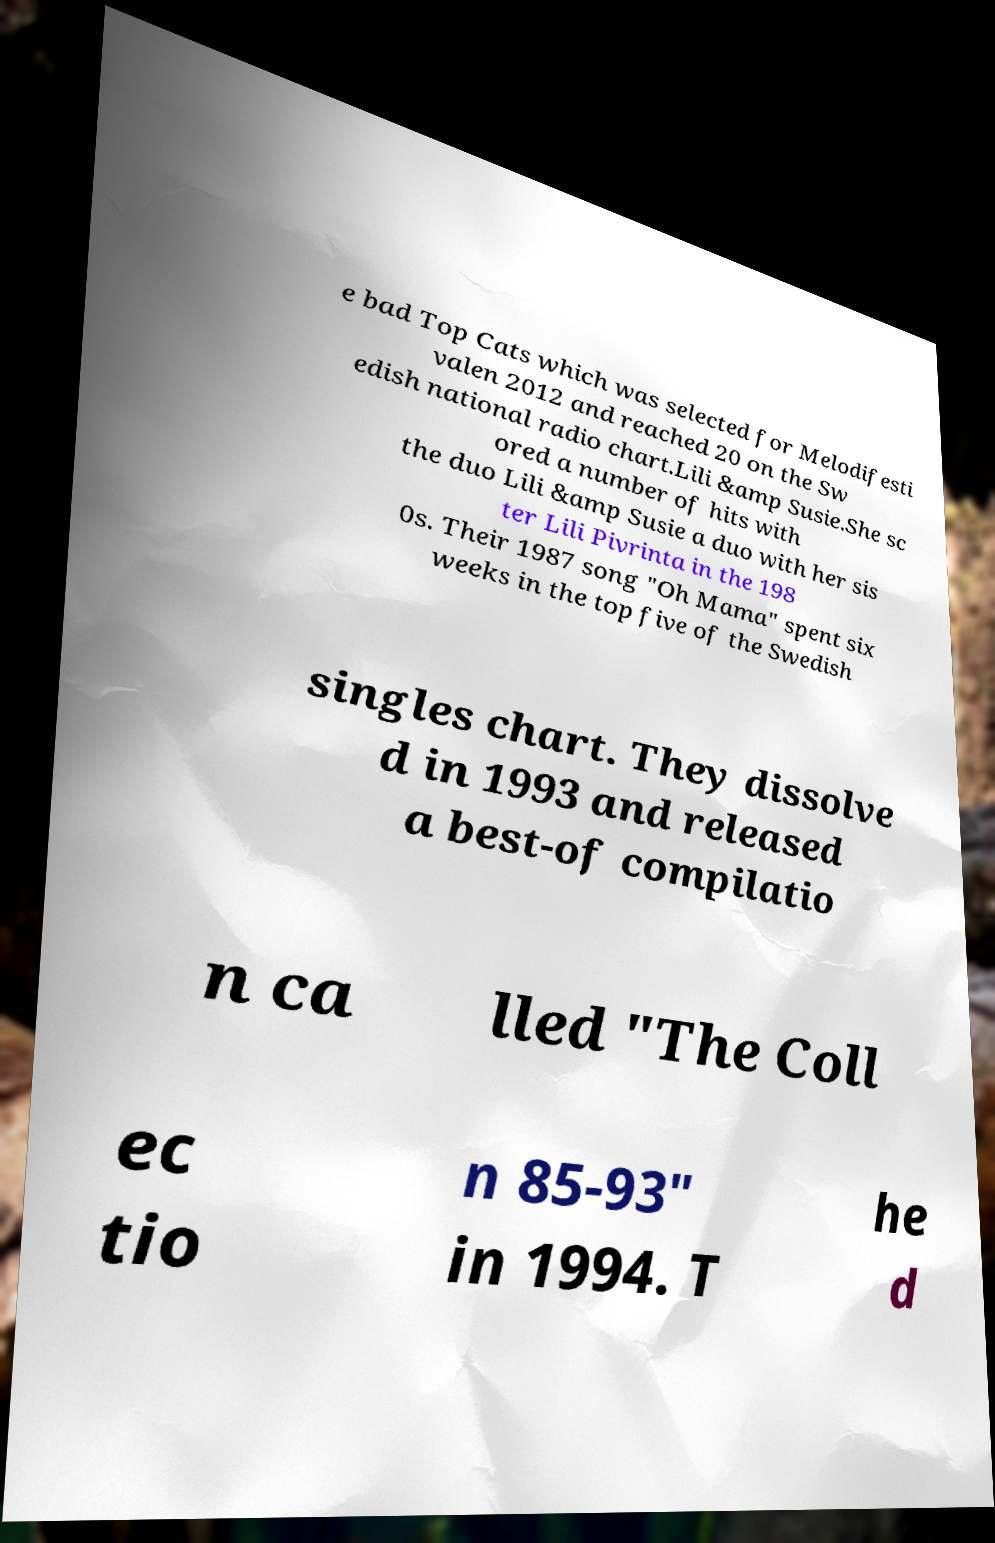For documentation purposes, I need the text within this image transcribed. Could you provide that? e bad Top Cats which was selected for Melodifesti valen 2012 and reached 20 on the Sw edish national radio chart.Lili &amp Susie.She sc ored a number of hits with the duo Lili &amp Susie a duo with her sis ter Lili Pivrinta in the 198 0s. Their 1987 song "Oh Mama" spent six weeks in the top five of the Swedish singles chart. They dissolve d in 1993 and released a best-of compilatio n ca lled "The Coll ec tio n 85-93" in 1994. T he d 